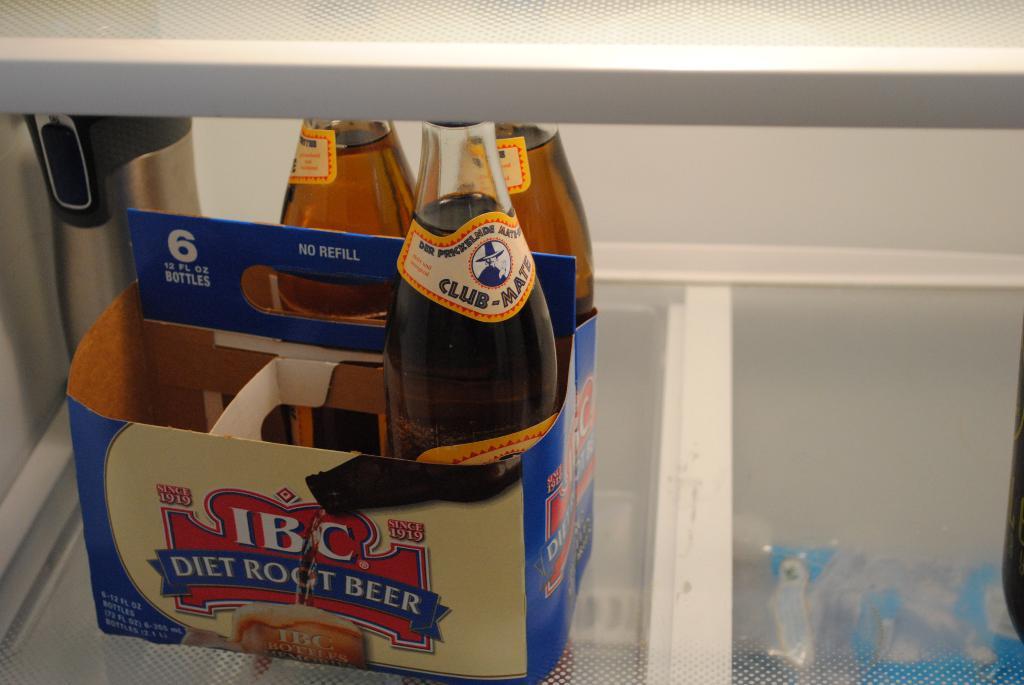What kind of root beer does the box say it is?
Ensure brevity in your answer.  Diet. What brand is this root beer?
Give a very brief answer. Ibc. 